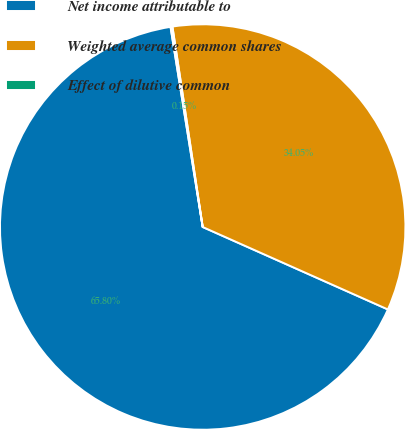Convert chart. <chart><loc_0><loc_0><loc_500><loc_500><pie_chart><fcel>Net income attributable to<fcel>Weighted average common shares<fcel>Effect of dilutive common<nl><fcel>65.79%<fcel>34.05%<fcel>0.15%<nl></chart> 